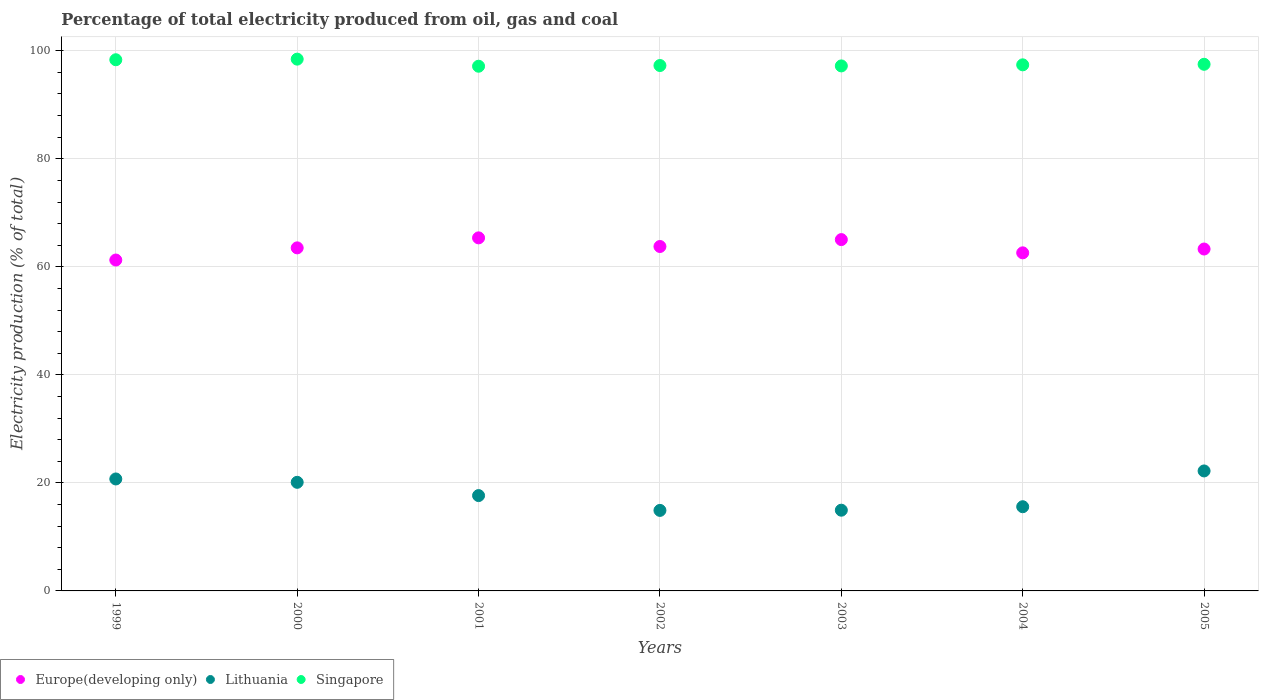What is the electricity production in in Singapore in 2000?
Give a very brief answer. 98.45. Across all years, what is the maximum electricity production in in Lithuania?
Make the answer very short. 22.21. Across all years, what is the minimum electricity production in in Europe(developing only)?
Keep it short and to the point. 61.26. In which year was the electricity production in in Europe(developing only) maximum?
Make the answer very short. 2001. In which year was the electricity production in in Europe(developing only) minimum?
Provide a short and direct response. 1999. What is the total electricity production in in Europe(developing only) in the graph?
Provide a short and direct response. 444.83. What is the difference between the electricity production in in Singapore in 2001 and that in 2005?
Offer a terse response. -0.36. What is the difference between the electricity production in in Singapore in 1999 and the electricity production in in Lithuania in 2005?
Give a very brief answer. 76.13. What is the average electricity production in in Europe(developing only) per year?
Your answer should be compact. 63.55. In the year 2004, what is the difference between the electricity production in in Lithuania and electricity production in in Europe(developing only)?
Offer a terse response. -47. In how many years, is the electricity production in in Singapore greater than 24 %?
Offer a very short reply. 7. What is the ratio of the electricity production in in Europe(developing only) in 2002 to that in 2005?
Your answer should be compact. 1.01. Is the electricity production in in Singapore in 2002 less than that in 2004?
Give a very brief answer. Yes. Is the difference between the electricity production in in Lithuania in 1999 and 2001 greater than the difference between the electricity production in in Europe(developing only) in 1999 and 2001?
Ensure brevity in your answer.  Yes. What is the difference between the highest and the second highest electricity production in in Singapore?
Your answer should be very brief. 0.11. What is the difference between the highest and the lowest electricity production in in Lithuania?
Your response must be concise. 7.31. In how many years, is the electricity production in in Singapore greater than the average electricity production in in Singapore taken over all years?
Offer a terse response. 2. Is it the case that in every year, the sum of the electricity production in in Europe(developing only) and electricity production in in Singapore  is greater than the electricity production in in Lithuania?
Keep it short and to the point. Yes. Does the electricity production in in Singapore monotonically increase over the years?
Offer a terse response. No. Is the electricity production in in Europe(developing only) strictly less than the electricity production in in Lithuania over the years?
Make the answer very short. No. How many dotlines are there?
Make the answer very short. 3. How many years are there in the graph?
Provide a succinct answer. 7. What is the difference between two consecutive major ticks on the Y-axis?
Offer a terse response. 20. Where does the legend appear in the graph?
Your answer should be very brief. Bottom left. How are the legend labels stacked?
Provide a short and direct response. Horizontal. What is the title of the graph?
Ensure brevity in your answer.  Percentage of total electricity produced from oil, gas and coal. What is the label or title of the Y-axis?
Offer a very short reply. Electricity production (% of total). What is the Electricity production (% of total) of Europe(developing only) in 1999?
Provide a short and direct response. 61.26. What is the Electricity production (% of total) in Lithuania in 1999?
Offer a terse response. 20.73. What is the Electricity production (% of total) in Singapore in 1999?
Provide a succinct answer. 98.34. What is the Electricity production (% of total) of Europe(developing only) in 2000?
Your answer should be very brief. 63.51. What is the Electricity production (% of total) in Lithuania in 2000?
Your answer should be very brief. 20.11. What is the Electricity production (% of total) of Singapore in 2000?
Keep it short and to the point. 98.45. What is the Electricity production (% of total) in Europe(developing only) in 2001?
Make the answer very short. 65.36. What is the Electricity production (% of total) in Lithuania in 2001?
Your answer should be very brief. 17.65. What is the Electricity production (% of total) of Singapore in 2001?
Offer a terse response. 97.14. What is the Electricity production (% of total) of Europe(developing only) in 2002?
Your answer should be very brief. 63.76. What is the Electricity production (% of total) of Lithuania in 2002?
Offer a terse response. 14.91. What is the Electricity production (% of total) of Singapore in 2002?
Ensure brevity in your answer.  97.27. What is the Electricity production (% of total) of Europe(developing only) in 2003?
Keep it short and to the point. 65.04. What is the Electricity production (% of total) in Lithuania in 2003?
Ensure brevity in your answer.  14.95. What is the Electricity production (% of total) in Singapore in 2003?
Provide a succinct answer. 97.2. What is the Electricity production (% of total) in Europe(developing only) in 2004?
Provide a short and direct response. 62.59. What is the Electricity production (% of total) of Lithuania in 2004?
Make the answer very short. 15.59. What is the Electricity production (% of total) in Singapore in 2004?
Offer a terse response. 97.4. What is the Electricity production (% of total) of Europe(developing only) in 2005?
Provide a succinct answer. 63.3. What is the Electricity production (% of total) in Lithuania in 2005?
Offer a terse response. 22.21. What is the Electricity production (% of total) in Singapore in 2005?
Your answer should be very brief. 97.5. Across all years, what is the maximum Electricity production (% of total) in Europe(developing only)?
Your response must be concise. 65.36. Across all years, what is the maximum Electricity production (% of total) in Lithuania?
Your answer should be very brief. 22.21. Across all years, what is the maximum Electricity production (% of total) of Singapore?
Offer a terse response. 98.45. Across all years, what is the minimum Electricity production (% of total) in Europe(developing only)?
Offer a terse response. 61.26. Across all years, what is the minimum Electricity production (% of total) of Lithuania?
Offer a very short reply. 14.91. Across all years, what is the minimum Electricity production (% of total) in Singapore?
Your answer should be very brief. 97.14. What is the total Electricity production (% of total) of Europe(developing only) in the graph?
Your answer should be very brief. 444.83. What is the total Electricity production (% of total) of Lithuania in the graph?
Provide a succinct answer. 126.14. What is the total Electricity production (% of total) of Singapore in the graph?
Your response must be concise. 683.3. What is the difference between the Electricity production (% of total) in Europe(developing only) in 1999 and that in 2000?
Your response must be concise. -2.25. What is the difference between the Electricity production (% of total) in Lithuania in 1999 and that in 2000?
Your answer should be very brief. 0.62. What is the difference between the Electricity production (% of total) of Singapore in 1999 and that in 2000?
Make the answer very short. -0.11. What is the difference between the Electricity production (% of total) of Europe(developing only) in 1999 and that in 2001?
Give a very brief answer. -4.1. What is the difference between the Electricity production (% of total) in Lithuania in 1999 and that in 2001?
Make the answer very short. 3.08. What is the difference between the Electricity production (% of total) in Singapore in 1999 and that in 2001?
Offer a terse response. 1.2. What is the difference between the Electricity production (% of total) of Europe(developing only) in 1999 and that in 2002?
Your answer should be very brief. -2.5. What is the difference between the Electricity production (% of total) in Lithuania in 1999 and that in 2002?
Your response must be concise. 5.82. What is the difference between the Electricity production (% of total) of Singapore in 1999 and that in 2002?
Ensure brevity in your answer.  1.07. What is the difference between the Electricity production (% of total) in Europe(developing only) in 1999 and that in 2003?
Ensure brevity in your answer.  -3.78. What is the difference between the Electricity production (% of total) of Lithuania in 1999 and that in 2003?
Your response must be concise. 5.78. What is the difference between the Electricity production (% of total) of Singapore in 1999 and that in 2003?
Provide a succinct answer. 1.14. What is the difference between the Electricity production (% of total) of Europe(developing only) in 1999 and that in 2004?
Offer a very short reply. -1.33. What is the difference between the Electricity production (% of total) of Lithuania in 1999 and that in 2004?
Offer a terse response. 5.14. What is the difference between the Electricity production (% of total) in Singapore in 1999 and that in 2004?
Your answer should be compact. 0.94. What is the difference between the Electricity production (% of total) in Europe(developing only) in 1999 and that in 2005?
Offer a very short reply. -2.04. What is the difference between the Electricity production (% of total) in Lithuania in 1999 and that in 2005?
Your response must be concise. -1.49. What is the difference between the Electricity production (% of total) of Singapore in 1999 and that in 2005?
Your answer should be compact. 0.84. What is the difference between the Electricity production (% of total) of Europe(developing only) in 2000 and that in 2001?
Provide a succinct answer. -1.85. What is the difference between the Electricity production (% of total) of Lithuania in 2000 and that in 2001?
Ensure brevity in your answer.  2.46. What is the difference between the Electricity production (% of total) of Singapore in 2000 and that in 2001?
Keep it short and to the point. 1.31. What is the difference between the Electricity production (% of total) of Europe(developing only) in 2000 and that in 2002?
Give a very brief answer. -0.25. What is the difference between the Electricity production (% of total) of Lithuania in 2000 and that in 2002?
Provide a short and direct response. 5.2. What is the difference between the Electricity production (% of total) in Singapore in 2000 and that in 2002?
Keep it short and to the point. 1.18. What is the difference between the Electricity production (% of total) in Europe(developing only) in 2000 and that in 2003?
Give a very brief answer. -1.53. What is the difference between the Electricity production (% of total) of Lithuania in 2000 and that in 2003?
Your answer should be very brief. 5.16. What is the difference between the Electricity production (% of total) in Singapore in 2000 and that in 2003?
Your response must be concise. 1.25. What is the difference between the Electricity production (% of total) of Europe(developing only) in 2000 and that in 2004?
Your response must be concise. 0.92. What is the difference between the Electricity production (% of total) in Lithuania in 2000 and that in 2004?
Offer a terse response. 4.52. What is the difference between the Electricity production (% of total) of Singapore in 2000 and that in 2004?
Keep it short and to the point. 1.05. What is the difference between the Electricity production (% of total) in Europe(developing only) in 2000 and that in 2005?
Provide a short and direct response. 0.21. What is the difference between the Electricity production (% of total) in Lithuania in 2000 and that in 2005?
Keep it short and to the point. -2.11. What is the difference between the Electricity production (% of total) of Singapore in 2000 and that in 2005?
Give a very brief answer. 0.95. What is the difference between the Electricity production (% of total) in Europe(developing only) in 2001 and that in 2002?
Your answer should be compact. 1.6. What is the difference between the Electricity production (% of total) of Lithuania in 2001 and that in 2002?
Keep it short and to the point. 2.74. What is the difference between the Electricity production (% of total) of Singapore in 2001 and that in 2002?
Provide a short and direct response. -0.13. What is the difference between the Electricity production (% of total) in Europe(developing only) in 2001 and that in 2003?
Offer a very short reply. 0.32. What is the difference between the Electricity production (% of total) of Lithuania in 2001 and that in 2003?
Make the answer very short. 2.7. What is the difference between the Electricity production (% of total) in Singapore in 2001 and that in 2003?
Provide a short and direct response. -0.06. What is the difference between the Electricity production (% of total) in Europe(developing only) in 2001 and that in 2004?
Provide a short and direct response. 2.77. What is the difference between the Electricity production (% of total) in Lithuania in 2001 and that in 2004?
Provide a succinct answer. 2.06. What is the difference between the Electricity production (% of total) in Singapore in 2001 and that in 2004?
Your response must be concise. -0.26. What is the difference between the Electricity production (% of total) of Europe(developing only) in 2001 and that in 2005?
Your answer should be compact. 2.07. What is the difference between the Electricity production (% of total) in Lithuania in 2001 and that in 2005?
Your response must be concise. -4.56. What is the difference between the Electricity production (% of total) of Singapore in 2001 and that in 2005?
Offer a very short reply. -0.36. What is the difference between the Electricity production (% of total) of Europe(developing only) in 2002 and that in 2003?
Your answer should be compact. -1.28. What is the difference between the Electricity production (% of total) in Lithuania in 2002 and that in 2003?
Ensure brevity in your answer.  -0.04. What is the difference between the Electricity production (% of total) in Singapore in 2002 and that in 2003?
Keep it short and to the point. 0.07. What is the difference between the Electricity production (% of total) in Europe(developing only) in 2002 and that in 2004?
Give a very brief answer. 1.17. What is the difference between the Electricity production (% of total) of Lithuania in 2002 and that in 2004?
Give a very brief answer. -0.68. What is the difference between the Electricity production (% of total) in Singapore in 2002 and that in 2004?
Make the answer very short. -0.13. What is the difference between the Electricity production (% of total) of Europe(developing only) in 2002 and that in 2005?
Provide a succinct answer. 0.47. What is the difference between the Electricity production (% of total) of Lithuania in 2002 and that in 2005?
Keep it short and to the point. -7.31. What is the difference between the Electricity production (% of total) of Singapore in 2002 and that in 2005?
Provide a succinct answer. -0.23. What is the difference between the Electricity production (% of total) of Europe(developing only) in 2003 and that in 2004?
Provide a succinct answer. 2.45. What is the difference between the Electricity production (% of total) in Lithuania in 2003 and that in 2004?
Offer a very short reply. -0.64. What is the difference between the Electricity production (% of total) in Singapore in 2003 and that in 2004?
Your answer should be very brief. -0.2. What is the difference between the Electricity production (% of total) of Europe(developing only) in 2003 and that in 2005?
Make the answer very short. 1.75. What is the difference between the Electricity production (% of total) of Lithuania in 2003 and that in 2005?
Provide a succinct answer. -7.27. What is the difference between the Electricity production (% of total) of Singapore in 2003 and that in 2005?
Your answer should be very brief. -0.3. What is the difference between the Electricity production (% of total) in Europe(developing only) in 2004 and that in 2005?
Your response must be concise. -0.71. What is the difference between the Electricity production (% of total) of Lithuania in 2004 and that in 2005?
Ensure brevity in your answer.  -6.63. What is the difference between the Electricity production (% of total) of Singapore in 2004 and that in 2005?
Provide a succinct answer. -0.1. What is the difference between the Electricity production (% of total) of Europe(developing only) in 1999 and the Electricity production (% of total) of Lithuania in 2000?
Your response must be concise. 41.15. What is the difference between the Electricity production (% of total) in Europe(developing only) in 1999 and the Electricity production (% of total) in Singapore in 2000?
Your response must be concise. -37.19. What is the difference between the Electricity production (% of total) in Lithuania in 1999 and the Electricity production (% of total) in Singapore in 2000?
Keep it short and to the point. -77.73. What is the difference between the Electricity production (% of total) of Europe(developing only) in 1999 and the Electricity production (% of total) of Lithuania in 2001?
Offer a terse response. 43.61. What is the difference between the Electricity production (% of total) in Europe(developing only) in 1999 and the Electricity production (% of total) in Singapore in 2001?
Keep it short and to the point. -35.88. What is the difference between the Electricity production (% of total) in Lithuania in 1999 and the Electricity production (% of total) in Singapore in 2001?
Keep it short and to the point. -76.41. What is the difference between the Electricity production (% of total) of Europe(developing only) in 1999 and the Electricity production (% of total) of Lithuania in 2002?
Provide a succinct answer. 46.35. What is the difference between the Electricity production (% of total) in Europe(developing only) in 1999 and the Electricity production (% of total) in Singapore in 2002?
Offer a terse response. -36.01. What is the difference between the Electricity production (% of total) in Lithuania in 1999 and the Electricity production (% of total) in Singapore in 2002?
Ensure brevity in your answer.  -76.54. What is the difference between the Electricity production (% of total) in Europe(developing only) in 1999 and the Electricity production (% of total) in Lithuania in 2003?
Offer a terse response. 46.31. What is the difference between the Electricity production (% of total) of Europe(developing only) in 1999 and the Electricity production (% of total) of Singapore in 2003?
Offer a terse response. -35.94. What is the difference between the Electricity production (% of total) of Lithuania in 1999 and the Electricity production (% of total) of Singapore in 2003?
Keep it short and to the point. -76.47. What is the difference between the Electricity production (% of total) in Europe(developing only) in 1999 and the Electricity production (% of total) in Lithuania in 2004?
Your answer should be compact. 45.67. What is the difference between the Electricity production (% of total) in Europe(developing only) in 1999 and the Electricity production (% of total) in Singapore in 2004?
Your response must be concise. -36.14. What is the difference between the Electricity production (% of total) in Lithuania in 1999 and the Electricity production (% of total) in Singapore in 2004?
Offer a terse response. -76.67. What is the difference between the Electricity production (% of total) of Europe(developing only) in 1999 and the Electricity production (% of total) of Lithuania in 2005?
Offer a very short reply. 39.05. What is the difference between the Electricity production (% of total) in Europe(developing only) in 1999 and the Electricity production (% of total) in Singapore in 2005?
Provide a short and direct response. -36.24. What is the difference between the Electricity production (% of total) of Lithuania in 1999 and the Electricity production (% of total) of Singapore in 2005?
Give a very brief answer. -76.77. What is the difference between the Electricity production (% of total) in Europe(developing only) in 2000 and the Electricity production (% of total) in Lithuania in 2001?
Offer a very short reply. 45.86. What is the difference between the Electricity production (% of total) in Europe(developing only) in 2000 and the Electricity production (% of total) in Singapore in 2001?
Your answer should be compact. -33.63. What is the difference between the Electricity production (% of total) in Lithuania in 2000 and the Electricity production (% of total) in Singapore in 2001?
Offer a terse response. -77.03. What is the difference between the Electricity production (% of total) in Europe(developing only) in 2000 and the Electricity production (% of total) in Lithuania in 2002?
Provide a succinct answer. 48.6. What is the difference between the Electricity production (% of total) of Europe(developing only) in 2000 and the Electricity production (% of total) of Singapore in 2002?
Keep it short and to the point. -33.76. What is the difference between the Electricity production (% of total) of Lithuania in 2000 and the Electricity production (% of total) of Singapore in 2002?
Your answer should be very brief. -77.16. What is the difference between the Electricity production (% of total) of Europe(developing only) in 2000 and the Electricity production (% of total) of Lithuania in 2003?
Provide a succinct answer. 48.57. What is the difference between the Electricity production (% of total) of Europe(developing only) in 2000 and the Electricity production (% of total) of Singapore in 2003?
Provide a short and direct response. -33.69. What is the difference between the Electricity production (% of total) of Lithuania in 2000 and the Electricity production (% of total) of Singapore in 2003?
Provide a short and direct response. -77.09. What is the difference between the Electricity production (% of total) in Europe(developing only) in 2000 and the Electricity production (% of total) in Lithuania in 2004?
Provide a short and direct response. 47.92. What is the difference between the Electricity production (% of total) of Europe(developing only) in 2000 and the Electricity production (% of total) of Singapore in 2004?
Provide a short and direct response. -33.89. What is the difference between the Electricity production (% of total) of Lithuania in 2000 and the Electricity production (% of total) of Singapore in 2004?
Keep it short and to the point. -77.29. What is the difference between the Electricity production (% of total) in Europe(developing only) in 2000 and the Electricity production (% of total) in Lithuania in 2005?
Ensure brevity in your answer.  41.3. What is the difference between the Electricity production (% of total) in Europe(developing only) in 2000 and the Electricity production (% of total) in Singapore in 2005?
Make the answer very short. -33.99. What is the difference between the Electricity production (% of total) of Lithuania in 2000 and the Electricity production (% of total) of Singapore in 2005?
Provide a succinct answer. -77.39. What is the difference between the Electricity production (% of total) in Europe(developing only) in 2001 and the Electricity production (% of total) in Lithuania in 2002?
Make the answer very short. 50.46. What is the difference between the Electricity production (% of total) of Europe(developing only) in 2001 and the Electricity production (% of total) of Singapore in 2002?
Give a very brief answer. -31.91. What is the difference between the Electricity production (% of total) of Lithuania in 2001 and the Electricity production (% of total) of Singapore in 2002?
Offer a terse response. -79.62. What is the difference between the Electricity production (% of total) in Europe(developing only) in 2001 and the Electricity production (% of total) in Lithuania in 2003?
Give a very brief answer. 50.42. What is the difference between the Electricity production (% of total) of Europe(developing only) in 2001 and the Electricity production (% of total) of Singapore in 2003?
Provide a short and direct response. -31.83. What is the difference between the Electricity production (% of total) in Lithuania in 2001 and the Electricity production (% of total) in Singapore in 2003?
Offer a terse response. -79.55. What is the difference between the Electricity production (% of total) in Europe(developing only) in 2001 and the Electricity production (% of total) in Lithuania in 2004?
Give a very brief answer. 49.78. What is the difference between the Electricity production (% of total) in Europe(developing only) in 2001 and the Electricity production (% of total) in Singapore in 2004?
Offer a terse response. -32.03. What is the difference between the Electricity production (% of total) of Lithuania in 2001 and the Electricity production (% of total) of Singapore in 2004?
Your response must be concise. -79.75. What is the difference between the Electricity production (% of total) in Europe(developing only) in 2001 and the Electricity production (% of total) in Lithuania in 2005?
Your response must be concise. 43.15. What is the difference between the Electricity production (% of total) of Europe(developing only) in 2001 and the Electricity production (% of total) of Singapore in 2005?
Keep it short and to the point. -32.13. What is the difference between the Electricity production (% of total) in Lithuania in 2001 and the Electricity production (% of total) in Singapore in 2005?
Your answer should be very brief. -79.85. What is the difference between the Electricity production (% of total) of Europe(developing only) in 2002 and the Electricity production (% of total) of Lithuania in 2003?
Provide a succinct answer. 48.82. What is the difference between the Electricity production (% of total) of Europe(developing only) in 2002 and the Electricity production (% of total) of Singapore in 2003?
Give a very brief answer. -33.43. What is the difference between the Electricity production (% of total) of Lithuania in 2002 and the Electricity production (% of total) of Singapore in 2003?
Your answer should be very brief. -82.29. What is the difference between the Electricity production (% of total) of Europe(developing only) in 2002 and the Electricity production (% of total) of Lithuania in 2004?
Provide a short and direct response. 48.18. What is the difference between the Electricity production (% of total) in Europe(developing only) in 2002 and the Electricity production (% of total) in Singapore in 2004?
Ensure brevity in your answer.  -33.63. What is the difference between the Electricity production (% of total) of Lithuania in 2002 and the Electricity production (% of total) of Singapore in 2004?
Make the answer very short. -82.49. What is the difference between the Electricity production (% of total) of Europe(developing only) in 2002 and the Electricity production (% of total) of Lithuania in 2005?
Provide a succinct answer. 41.55. What is the difference between the Electricity production (% of total) in Europe(developing only) in 2002 and the Electricity production (% of total) in Singapore in 2005?
Your answer should be compact. -33.73. What is the difference between the Electricity production (% of total) in Lithuania in 2002 and the Electricity production (% of total) in Singapore in 2005?
Offer a very short reply. -82.59. What is the difference between the Electricity production (% of total) in Europe(developing only) in 2003 and the Electricity production (% of total) in Lithuania in 2004?
Offer a terse response. 49.46. What is the difference between the Electricity production (% of total) in Europe(developing only) in 2003 and the Electricity production (% of total) in Singapore in 2004?
Give a very brief answer. -32.35. What is the difference between the Electricity production (% of total) of Lithuania in 2003 and the Electricity production (% of total) of Singapore in 2004?
Offer a terse response. -82.45. What is the difference between the Electricity production (% of total) of Europe(developing only) in 2003 and the Electricity production (% of total) of Lithuania in 2005?
Provide a succinct answer. 42.83. What is the difference between the Electricity production (% of total) in Europe(developing only) in 2003 and the Electricity production (% of total) in Singapore in 2005?
Provide a short and direct response. -32.46. What is the difference between the Electricity production (% of total) of Lithuania in 2003 and the Electricity production (% of total) of Singapore in 2005?
Your response must be concise. -82.55. What is the difference between the Electricity production (% of total) of Europe(developing only) in 2004 and the Electricity production (% of total) of Lithuania in 2005?
Keep it short and to the point. 40.38. What is the difference between the Electricity production (% of total) in Europe(developing only) in 2004 and the Electricity production (% of total) in Singapore in 2005?
Provide a succinct answer. -34.91. What is the difference between the Electricity production (% of total) in Lithuania in 2004 and the Electricity production (% of total) in Singapore in 2005?
Offer a very short reply. -81.91. What is the average Electricity production (% of total) of Europe(developing only) per year?
Provide a short and direct response. 63.55. What is the average Electricity production (% of total) of Lithuania per year?
Make the answer very short. 18.02. What is the average Electricity production (% of total) in Singapore per year?
Make the answer very short. 97.61. In the year 1999, what is the difference between the Electricity production (% of total) in Europe(developing only) and Electricity production (% of total) in Lithuania?
Offer a very short reply. 40.53. In the year 1999, what is the difference between the Electricity production (% of total) in Europe(developing only) and Electricity production (% of total) in Singapore?
Your response must be concise. -37.08. In the year 1999, what is the difference between the Electricity production (% of total) in Lithuania and Electricity production (% of total) in Singapore?
Your response must be concise. -77.61. In the year 2000, what is the difference between the Electricity production (% of total) in Europe(developing only) and Electricity production (% of total) in Lithuania?
Give a very brief answer. 43.41. In the year 2000, what is the difference between the Electricity production (% of total) in Europe(developing only) and Electricity production (% of total) in Singapore?
Offer a terse response. -34.94. In the year 2000, what is the difference between the Electricity production (% of total) of Lithuania and Electricity production (% of total) of Singapore?
Your answer should be very brief. -78.35. In the year 2001, what is the difference between the Electricity production (% of total) of Europe(developing only) and Electricity production (% of total) of Lithuania?
Your answer should be compact. 47.71. In the year 2001, what is the difference between the Electricity production (% of total) of Europe(developing only) and Electricity production (% of total) of Singapore?
Ensure brevity in your answer.  -31.78. In the year 2001, what is the difference between the Electricity production (% of total) in Lithuania and Electricity production (% of total) in Singapore?
Give a very brief answer. -79.49. In the year 2002, what is the difference between the Electricity production (% of total) of Europe(developing only) and Electricity production (% of total) of Lithuania?
Your answer should be very brief. 48.86. In the year 2002, what is the difference between the Electricity production (% of total) in Europe(developing only) and Electricity production (% of total) in Singapore?
Keep it short and to the point. -33.51. In the year 2002, what is the difference between the Electricity production (% of total) of Lithuania and Electricity production (% of total) of Singapore?
Provide a short and direct response. -82.36. In the year 2003, what is the difference between the Electricity production (% of total) in Europe(developing only) and Electricity production (% of total) in Lithuania?
Ensure brevity in your answer.  50.1. In the year 2003, what is the difference between the Electricity production (% of total) of Europe(developing only) and Electricity production (% of total) of Singapore?
Make the answer very short. -32.15. In the year 2003, what is the difference between the Electricity production (% of total) of Lithuania and Electricity production (% of total) of Singapore?
Provide a short and direct response. -82.25. In the year 2004, what is the difference between the Electricity production (% of total) in Europe(developing only) and Electricity production (% of total) in Lithuania?
Your answer should be very brief. 47. In the year 2004, what is the difference between the Electricity production (% of total) in Europe(developing only) and Electricity production (% of total) in Singapore?
Offer a terse response. -34.81. In the year 2004, what is the difference between the Electricity production (% of total) of Lithuania and Electricity production (% of total) of Singapore?
Keep it short and to the point. -81.81. In the year 2005, what is the difference between the Electricity production (% of total) of Europe(developing only) and Electricity production (% of total) of Lithuania?
Your answer should be very brief. 41.08. In the year 2005, what is the difference between the Electricity production (% of total) of Europe(developing only) and Electricity production (% of total) of Singapore?
Provide a short and direct response. -34.2. In the year 2005, what is the difference between the Electricity production (% of total) in Lithuania and Electricity production (% of total) in Singapore?
Your answer should be compact. -75.29. What is the ratio of the Electricity production (% of total) in Europe(developing only) in 1999 to that in 2000?
Give a very brief answer. 0.96. What is the ratio of the Electricity production (% of total) in Lithuania in 1999 to that in 2000?
Make the answer very short. 1.03. What is the ratio of the Electricity production (% of total) in Singapore in 1999 to that in 2000?
Offer a terse response. 1. What is the ratio of the Electricity production (% of total) in Europe(developing only) in 1999 to that in 2001?
Provide a short and direct response. 0.94. What is the ratio of the Electricity production (% of total) in Lithuania in 1999 to that in 2001?
Offer a very short reply. 1.17. What is the ratio of the Electricity production (% of total) of Singapore in 1999 to that in 2001?
Your answer should be compact. 1.01. What is the ratio of the Electricity production (% of total) of Europe(developing only) in 1999 to that in 2002?
Make the answer very short. 0.96. What is the ratio of the Electricity production (% of total) in Lithuania in 1999 to that in 2002?
Give a very brief answer. 1.39. What is the ratio of the Electricity production (% of total) of Europe(developing only) in 1999 to that in 2003?
Your answer should be very brief. 0.94. What is the ratio of the Electricity production (% of total) in Lithuania in 1999 to that in 2003?
Offer a terse response. 1.39. What is the ratio of the Electricity production (% of total) in Singapore in 1999 to that in 2003?
Provide a succinct answer. 1.01. What is the ratio of the Electricity production (% of total) in Europe(developing only) in 1999 to that in 2004?
Your response must be concise. 0.98. What is the ratio of the Electricity production (% of total) in Lithuania in 1999 to that in 2004?
Your answer should be very brief. 1.33. What is the ratio of the Electricity production (% of total) of Singapore in 1999 to that in 2004?
Keep it short and to the point. 1.01. What is the ratio of the Electricity production (% of total) in Europe(developing only) in 1999 to that in 2005?
Provide a short and direct response. 0.97. What is the ratio of the Electricity production (% of total) in Lithuania in 1999 to that in 2005?
Give a very brief answer. 0.93. What is the ratio of the Electricity production (% of total) of Singapore in 1999 to that in 2005?
Make the answer very short. 1.01. What is the ratio of the Electricity production (% of total) of Europe(developing only) in 2000 to that in 2001?
Your response must be concise. 0.97. What is the ratio of the Electricity production (% of total) of Lithuania in 2000 to that in 2001?
Provide a succinct answer. 1.14. What is the ratio of the Electricity production (% of total) of Singapore in 2000 to that in 2001?
Ensure brevity in your answer.  1.01. What is the ratio of the Electricity production (% of total) in Europe(developing only) in 2000 to that in 2002?
Provide a succinct answer. 1. What is the ratio of the Electricity production (% of total) of Lithuania in 2000 to that in 2002?
Offer a very short reply. 1.35. What is the ratio of the Electricity production (% of total) in Singapore in 2000 to that in 2002?
Your response must be concise. 1.01. What is the ratio of the Electricity production (% of total) in Europe(developing only) in 2000 to that in 2003?
Give a very brief answer. 0.98. What is the ratio of the Electricity production (% of total) of Lithuania in 2000 to that in 2003?
Keep it short and to the point. 1.35. What is the ratio of the Electricity production (% of total) in Singapore in 2000 to that in 2003?
Your answer should be very brief. 1.01. What is the ratio of the Electricity production (% of total) of Europe(developing only) in 2000 to that in 2004?
Make the answer very short. 1.01. What is the ratio of the Electricity production (% of total) in Lithuania in 2000 to that in 2004?
Give a very brief answer. 1.29. What is the ratio of the Electricity production (% of total) of Singapore in 2000 to that in 2004?
Your response must be concise. 1.01. What is the ratio of the Electricity production (% of total) in Lithuania in 2000 to that in 2005?
Your response must be concise. 0.91. What is the ratio of the Electricity production (% of total) in Singapore in 2000 to that in 2005?
Make the answer very short. 1.01. What is the ratio of the Electricity production (% of total) of Europe(developing only) in 2001 to that in 2002?
Offer a very short reply. 1.03. What is the ratio of the Electricity production (% of total) of Lithuania in 2001 to that in 2002?
Provide a succinct answer. 1.18. What is the ratio of the Electricity production (% of total) in Europe(developing only) in 2001 to that in 2003?
Offer a terse response. 1. What is the ratio of the Electricity production (% of total) in Lithuania in 2001 to that in 2003?
Your response must be concise. 1.18. What is the ratio of the Electricity production (% of total) of Europe(developing only) in 2001 to that in 2004?
Ensure brevity in your answer.  1.04. What is the ratio of the Electricity production (% of total) in Lithuania in 2001 to that in 2004?
Your answer should be very brief. 1.13. What is the ratio of the Electricity production (% of total) of Europe(developing only) in 2001 to that in 2005?
Provide a succinct answer. 1.03. What is the ratio of the Electricity production (% of total) in Lithuania in 2001 to that in 2005?
Offer a terse response. 0.79. What is the ratio of the Electricity production (% of total) in Singapore in 2001 to that in 2005?
Provide a succinct answer. 1. What is the ratio of the Electricity production (% of total) of Europe(developing only) in 2002 to that in 2003?
Keep it short and to the point. 0.98. What is the ratio of the Electricity production (% of total) of Lithuania in 2002 to that in 2003?
Offer a very short reply. 1. What is the ratio of the Electricity production (% of total) of Europe(developing only) in 2002 to that in 2004?
Keep it short and to the point. 1.02. What is the ratio of the Electricity production (% of total) of Lithuania in 2002 to that in 2004?
Give a very brief answer. 0.96. What is the ratio of the Electricity production (% of total) in Europe(developing only) in 2002 to that in 2005?
Your answer should be very brief. 1.01. What is the ratio of the Electricity production (% of total) of Lithuania in 2002 to that in 2005?
Provide a short and direct response. 0.67. What is the ratio of the Electricity production (% of total) of Singapore in 2002 to that in 2005?
Offer a terse response. 1. What is the ratio of the Electricity production (% of total) in Europe(developing only) in 2003 to that in 2004?
Provide a succinct answer. 1.04. What is the ratio of the Electricity production (% of total) in Lithuania in 2003 to that in 2004?
Keep it short and to the point. 0.96. What is the ratio of the Electricity production (% of total) of Europe(developing only) in 2003 to that in 2005?
Offer a terse response. 1.03. What is the ratio of the Electricity production (% of total) of Lithuania in 2003 to that in 2005?
Make the answer very short. 0.67. What is the ratio of the Electricity production (% of total) of Europe(developing only) in 2004 to that in 2005?
Make the answer very short. 0.99. What is the ratio of the Electricity production (% of total) of Lithuania in 2004 to that in 2005?
Your response must be concise. 0.7. What is the difference between the highest and the second highest Electricity production (% of total) in Europe(developing only)?
Your answer should be compact. 0.32. What is the difference between the highest and the second highest Electricity production (% of total) in Lithuania?
Keep it short and to the point. 1.49. What is the difference between the highest and the second highest Electricity production (% of total) in Singapore?
Your answer should be very brief. 0.11. What is the difference between the highest and the lowest Electricity production (% of total) of Europe(developing only)?
Your answer should be very brief. 4.1. What is the difference between the highest and the lowest Electricity production (% of total) in Lithuania?
Your response must be concise. 7.31. What is the difference between the highest and the lowest Electricity production (% of total) in Singapore?
Your answer should be very brief. 1.31. 